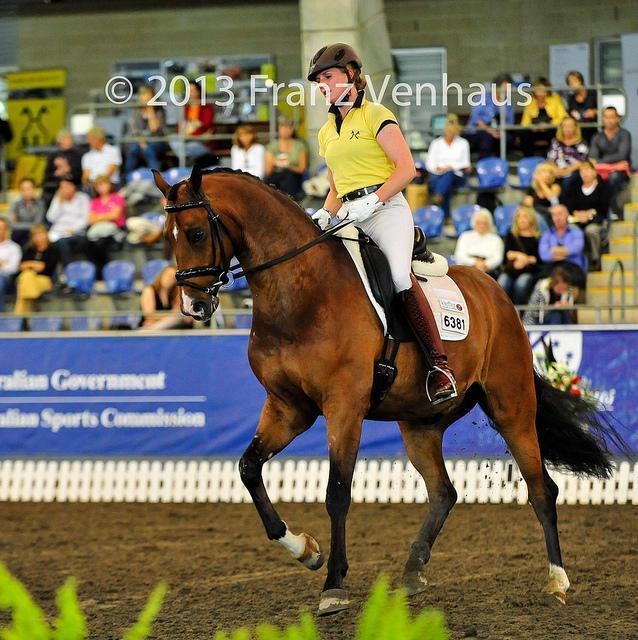How many horses are there?
Give a very brief answer. 1. How many people are there?
Give a very brief answer. 10. 